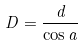<formula> <loc_0><loc_0><loc_500><loc_500>D = \frac { d } { \cos a }</formula> 